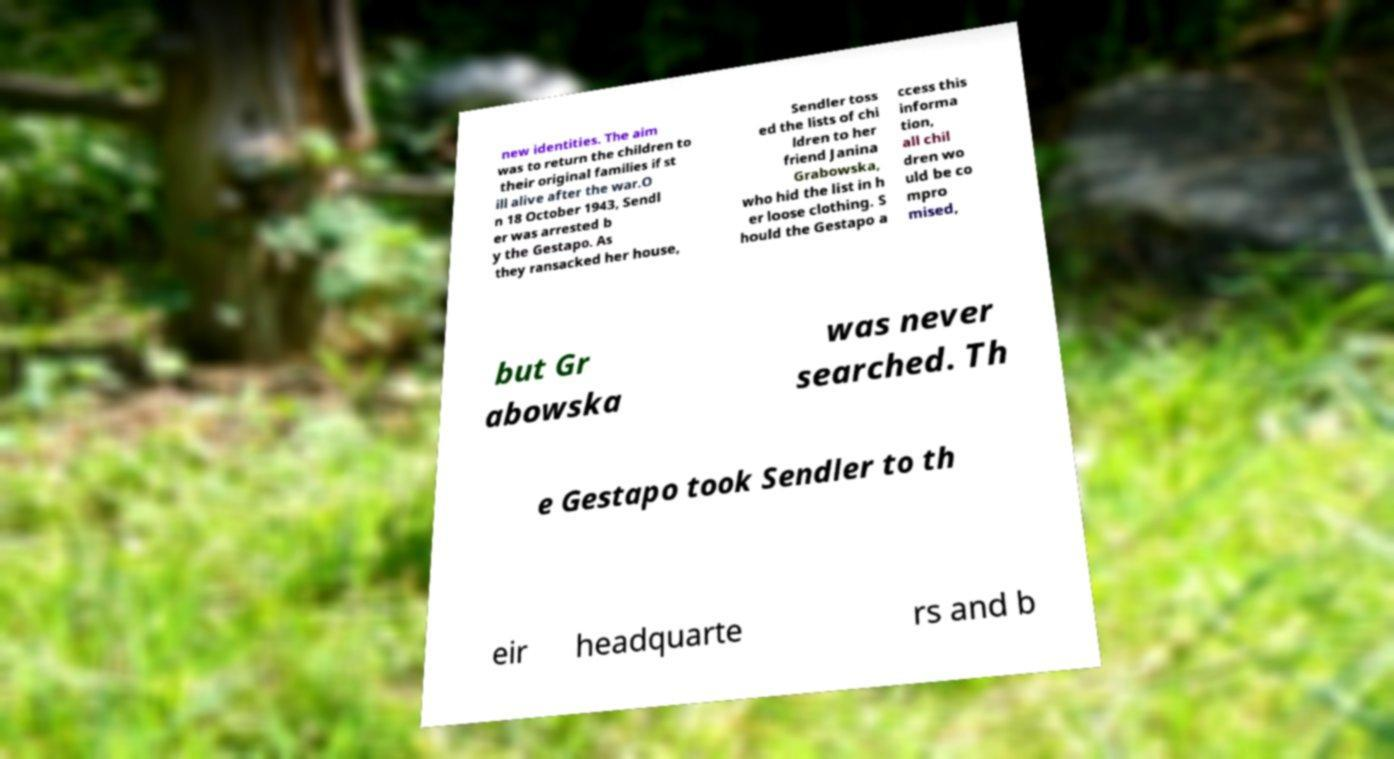Could you extract and type out the text from this image? new identities. The aim was to return the children to their original families if st ill alive after the war.O n 18 October 1943, Sendl er was arrested b y the Gestapo. As they ransacked her house, Sendler toss ed the lists of chi ldren to her friend Janina Grabowska, who hid the list in h er loose clothing. S hould the Gestapo a ccess this informa tion, all chil dren wo uld be co mpro mised, but Gr abowska was never searched. Th e Gestapo took Sendler to th eir headquarte rs and b 